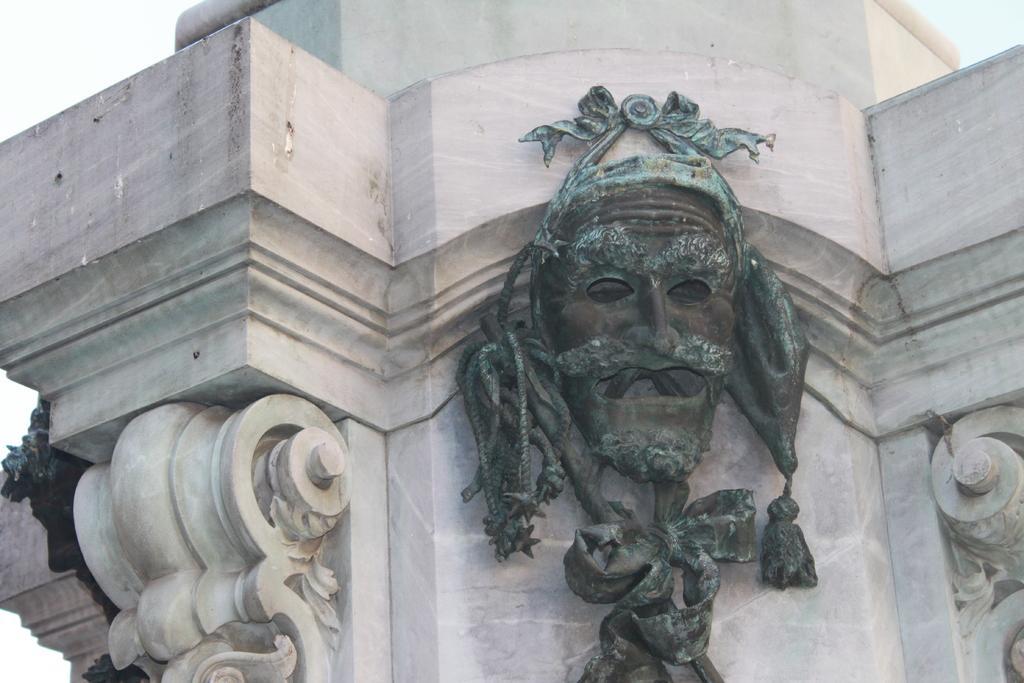How would you summarize this image in a sentence or two? In this image we can see there a mask hanged on the wall. 